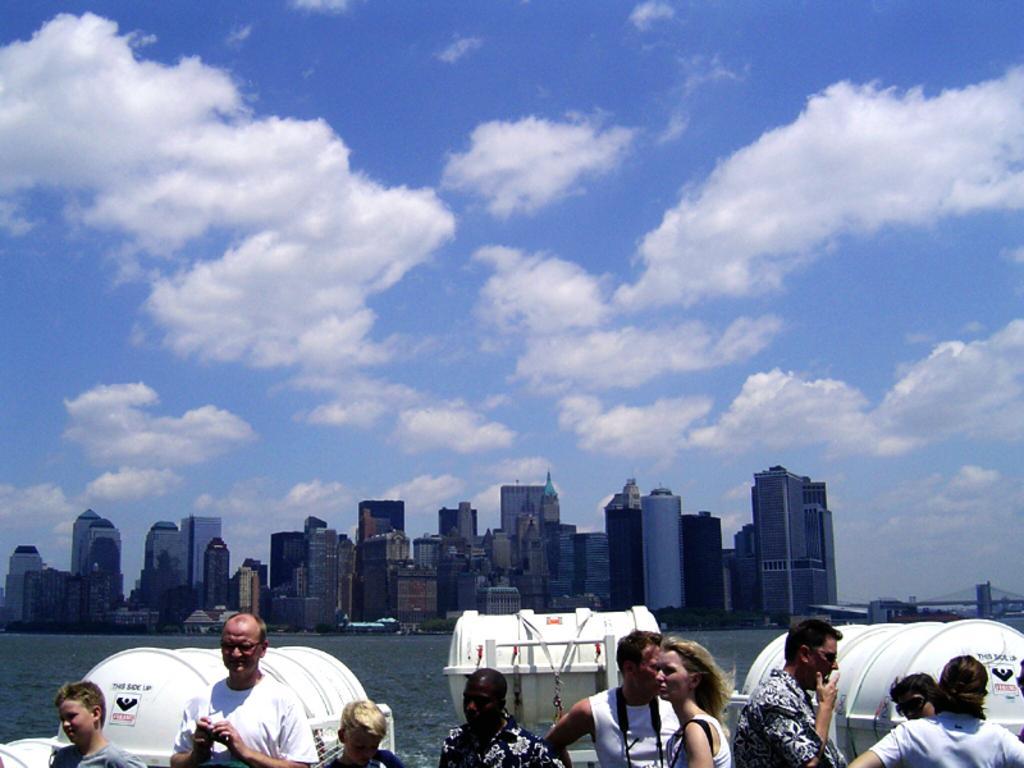In one or two sentences, can you explain what this image depicts? In this image, I can see water, buildings, lifeboat barrels and a bridge. At the bottom of the image, there are few people. In the background, there is the sky. 